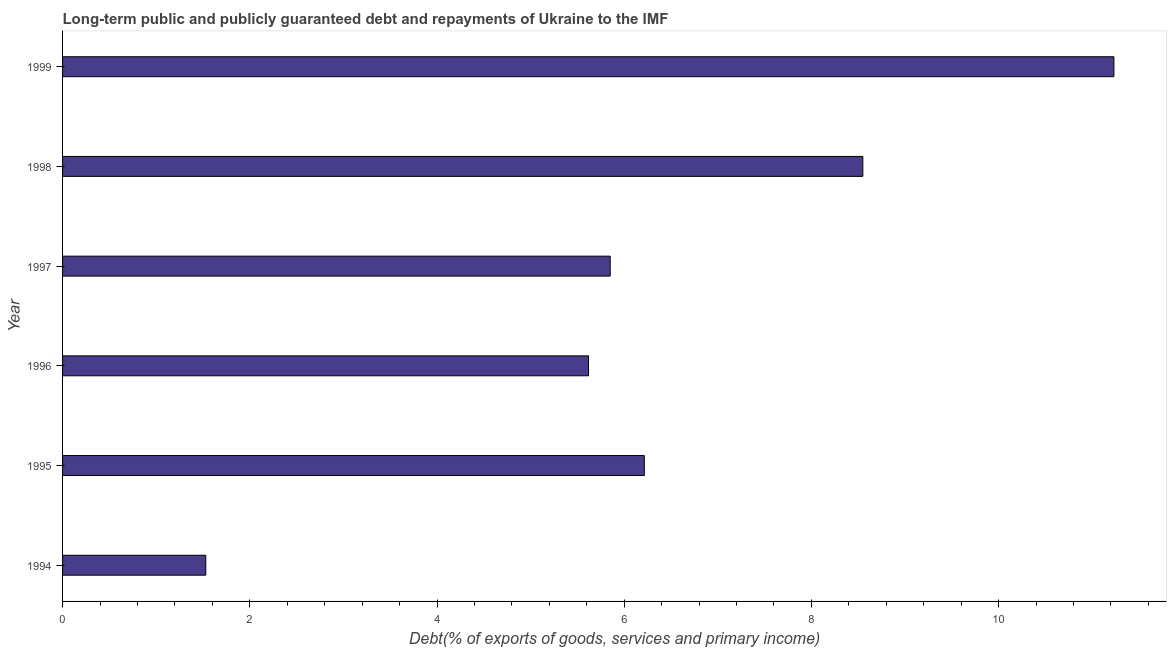What is the title of the graph?
Provide a succinct answer. Long-term public and publicly guaranteed debt and repayments of Ukraine to the IMF. What is the label or title of the X-axis?
Keep it short and to the point. Debt(% of exports of goods, services and primary income). What is the label or title of the Y-axis?
Provide a short and direct response. Year. What is the debt service in 1995?
Provide a short and direct response. 6.21. Across all years, what is the maximum debt service?
Provide a short and direct response. 11.23. Across all years, what is the minimum debt service?
Ensure brevity in your answer.  1.53. In which year was the debt service maximum?
Your answer should be very brief. 1999. What is the sum of the debt service?
Make the answer very short. 38.99. What is the difference between the debt service in 1995 and 1997?
Make the answer very short. 0.36. What is the average debt service per year?
Provide a succinct answer. 6.5. What is the median debt service?
Ensure brevity in your answer.  6.03. Do a majority of the years between 1998 and 1996 (inclusive) have debt service greater than 1.6 %?
Make the answer very short. Yes. What is the ratio of the debt service in 1998 to that in 1999?
Your answer should be very brief. 0.76. Is the debt service in 1994 less than that in 1995?
Make the answer very short. Yes. What is the difference between the highest and the second highest debt service?
Ensure brevity in your answer.  2.68. What is the difference between the highest and the lowest debt service?
Offer a terse response. 9.7. In how many years, is the debt service greater than the average debt service taken over all years?
Your answer should be very brief. 2. How many bars are there?
Give a very brief answer. 6. What is the Debt(% of exports of goods, services and primary income) of 1994?
Your answer should be very brief. 1.53. What is the Debt(% of exports of goods, services and primary income) of 1995?
Offer a very short reply. 6.21. What is the Debt(% of exports of goods, services and primary income) of 1996?
Your answer should be compact. 5.62. What is the Debt(% of exports of goods, services and primary income) in 1997?
Offer a terse response. 5.85. What is the Debt(% of exports of goods, services and primary income) of 1998?
Provide a short and direct response. 8.55. What is the Debt(% of exports of goods, services and primary income) in 1999?
Give a very brief answer. 11.23. What is the difference between the Debt(% of exports of goods, services and primary income) in 1994 and 1995?
Your answer should be compact. -4.68. What is the difference between the Debt(% of exports of goods, services and primary income) in 1994 and 1996?
Your response must be concise. -4.09. What is the difference between the Debt(% of exports of goods, services and primary income) in 1994 and 1997?
Provide a succinct answer. -4.32. What is the difference between the Debt(% of exports of goods, services and primary income) in 1994 and 1998?
Keep it short and to the point. -7.02. What is the difference between the Debt(% of exports of goods, services and primary income) in 1994 and 1999?
Provide a short and direct response. -9.7. What is the difference between the Debt(% of exports of goods, services and primary income) in 1995 and 1996?
Provide a short and direct response. 0.6. What is the difference between the Debt(% of exports of goods, services and primary income) in 1995 and 1997?
Offer a very short reply. 0.36. What is the difference between the Debt(% of exports of goods, services and primary income) in 1995 and 1998?
Provide a succinct answer. -2.33. What is the difference between the Debt(% of exports of goods, services and primary income) in 1995 and 1999?
Make the answer very short. -5.02. What is the difference between the Debt(% of exports of goods, services and primary income) in 1996 and 1997?
Provide a short and direct response. -0.23. What is the difference between the Debt(% of exports of goods, services and primary income) in 1996 and 1998?
Make the answer very short. -2.93. What is the difference between the Debt(% of exports of goods, services and primary income) in 1996 and 1999?
Offer a very short reply. -5.61. What is the difference between the Debt(% of exports of goods, services and primary income) in 1997 and 1998?
Your answer should be very brief. -2.7. What is the difference between the Debt(% of exports of goods, services and primary income) in 1997 and 1999?
Ensure brevity in your answer.  -5.38. What is the difference between the Debt(% of exports of goods, services and primary income) in 1998 and 1999?
Provide a short and direct response. -2.68. What is the ratio of the Debt(% of exports of goods, services and primary income) in 1994 to that in 1995?
Provide a succinct answer. 0.25. What is the ratio of the Debt(% of exports of goods, services and primary income) in 1994 to that in 1996?
Offer a very short reply. 0.27. What is the ratio of the Debt(% of exports of goods, services and primary income) in 1994 to that in 1997?
Ensure brevity in your answer.  0.26. What is the ratio of the Debt(% of exports of goods, services and primary income) in 1994 to that in 1998?
Provide a succinct answer. 0.18. What is the ratio of the Debt(% of exports of goods, services and primary income) in 1994 to that in 1999?
Offer a very short reply. 0.14. What is the ratio of the Debt(% of exports of goods, services and primary income) in 1995 to that in 1996?
Your answer should be very brief. 1.11. What is the ratio of the Debt(% of exports of goods, services and primary income) in 1995 to that in 1997?
Provide a short and direct response. 1.06. What is the ratio of the Debt(% of exports of goods, services and primary income) in 1995 to that in 1998?
Your response must be concise. 0.73. What is the ratio of the Debt(% of exports of goods, services and primary income) in 1995 to that in 1999?
Offer a terse response. 0.55. What is the ratio of the Debt(% of exports of goods, services and primary income) in 1996 to that in 1998?
Offer a terse response. 0.66. What is the ratio of the Debt(% of exports of goods, services and primary income) in 1996 to that in 1999?
Your answer should be very brief. 0.5. What is the ratio of the Debt(% of exports of goods, services and primary income) in 1997 to that in 1998?
Give a very brief answer. 0.68. What is the ratio of the Debt(% of exports of goods, services and primary income) in 1997 to that in 1999?
Ensure brevity in your answer.  0.52. What is the ratio of the Debt(% of exports of goods, services and primary income) in 1998 to that in 1999?
Your response must be concise. 0.76. 